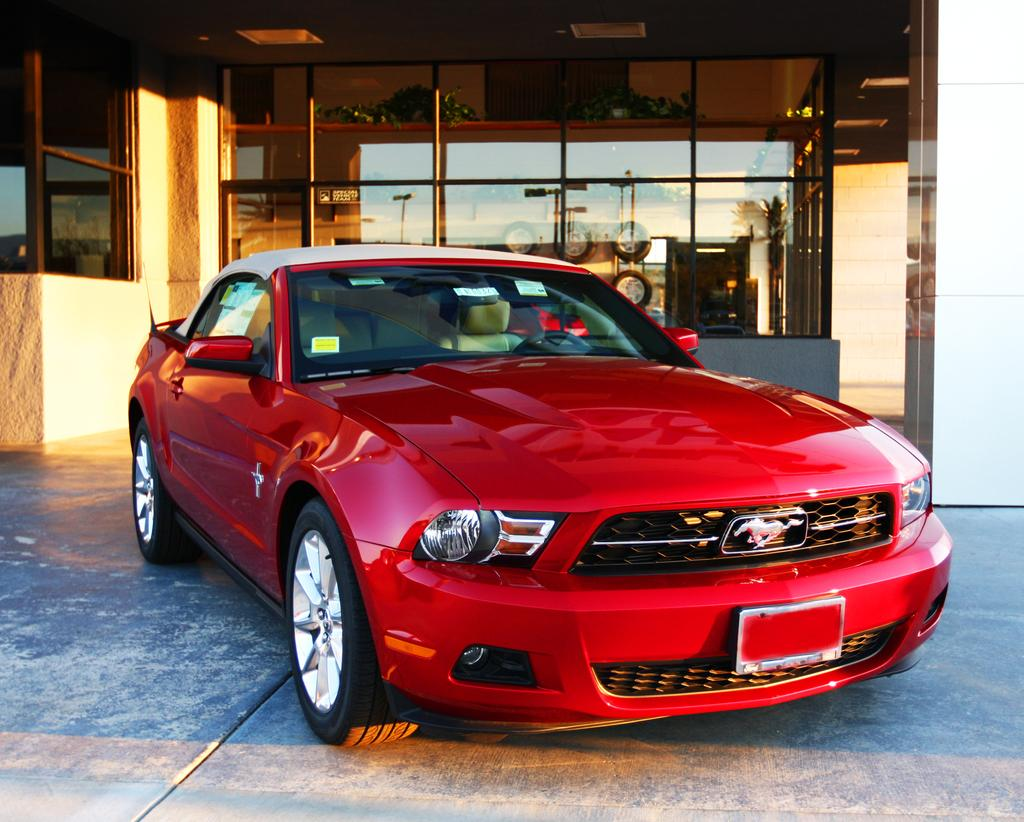What color is the vehicle in the image? The vehicle in the image is red. What can be seen in the background of the image? There are glass windows in the background of the image. What is visible through the glass windows? Wheels are visible through the glass windows. What is reflected on the glass windows? There is a reflection of light poles on the glass windows. How many bags can be seen in the image? There are no bags visible in the image. 